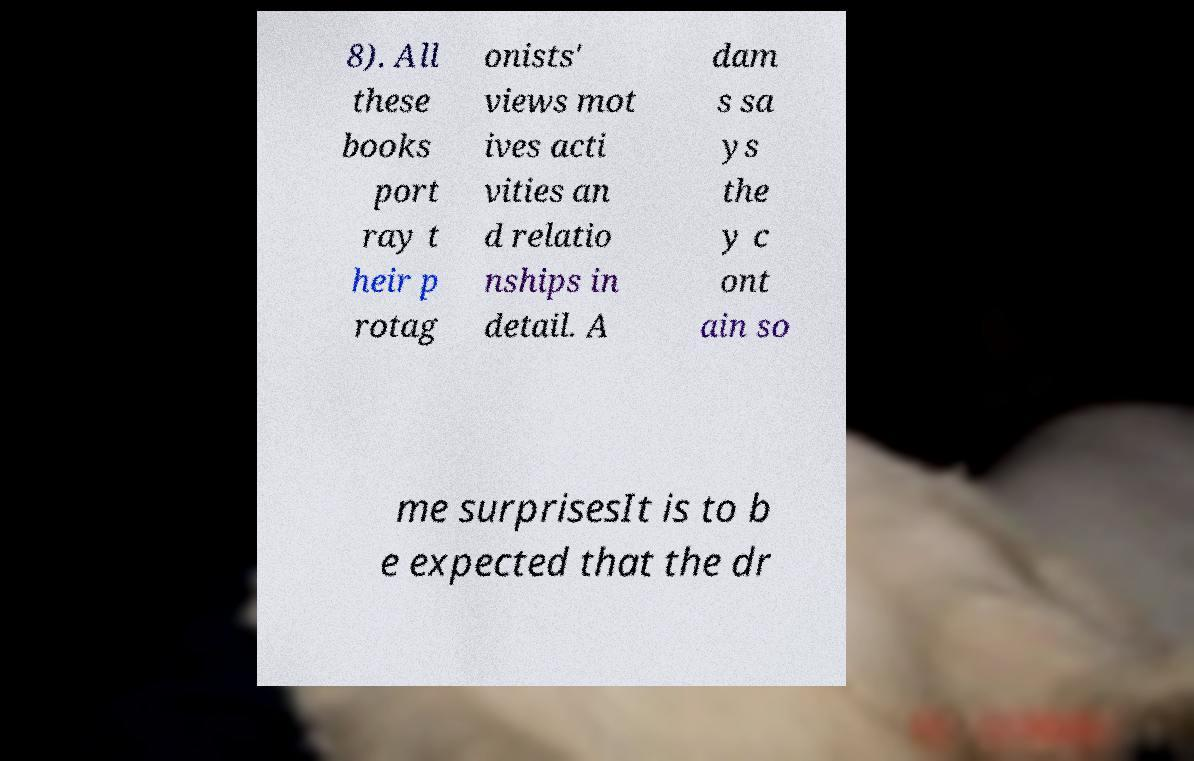What messages or text are displayed in this image? I need them in a readable, typed format. 8). All these books port ray t heir p rotag onists' views mot ives acti vities an d relatio nships in detail. A dam s sa ys the y c ont ain so me surprisesIt is to b e expected that the dr 